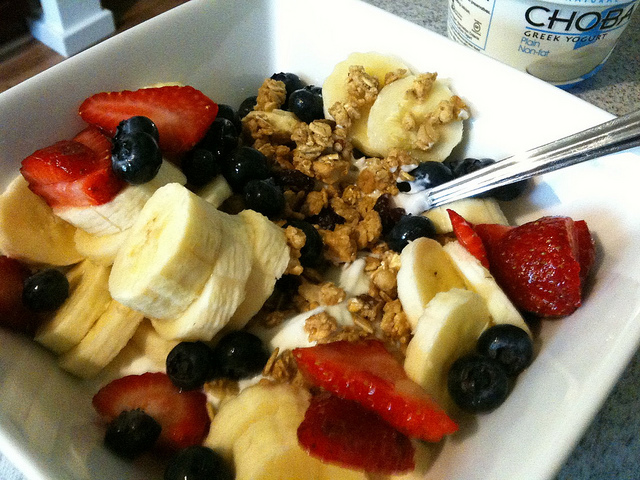Please extract the text content from this image. CHOBA YOGURT GREEK NOO 